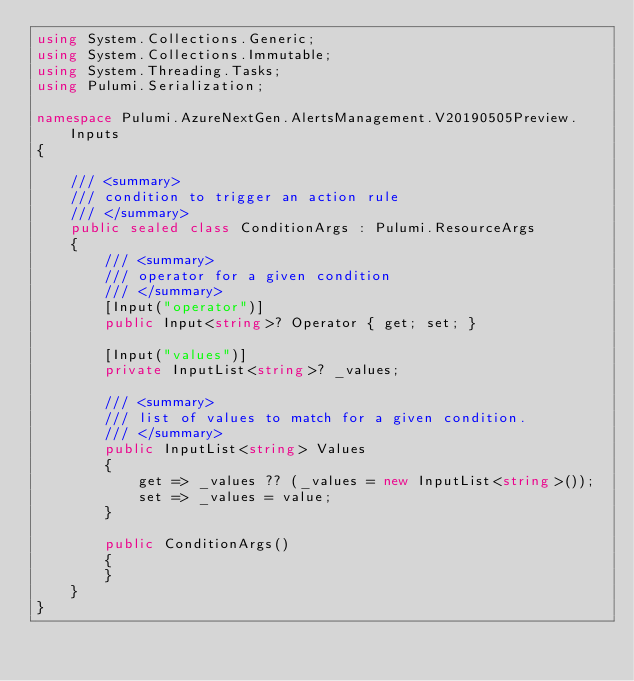<code> <loc_0><loc_0><loc_500><loc_500><_C#_>using System.Collections.Generic;
using System.Collections.Immutable;
using System.Threading.Tasks;
using Pulumi.Serialization;

namespace Pulumi.AzureNextGen.AlertsManagement.V20190505Preview.Inputs
{

    /// <summary>
    /// condition to trigger an action rule
    /// </summary>
    public sealed class ConditionArgs : Pulumi.ResourceArgs
    {
        /// <summary>
        /// operator for a given condition
        /// </summary>
        [Input("operator")]
        public Input<string>? Operator { get; set; }

        [Input("values")]
        private InputList<string>? _values;

        /// <summary>
        /// list of values to match for a given condition.
        /// </summary>
        public InputList<string> Values
        {
            get => _values ?? (_values = new InputList<string>());
            set => _values = value;
        }

        public ConditionArgs()
        {
        }
    }
}
</code> 